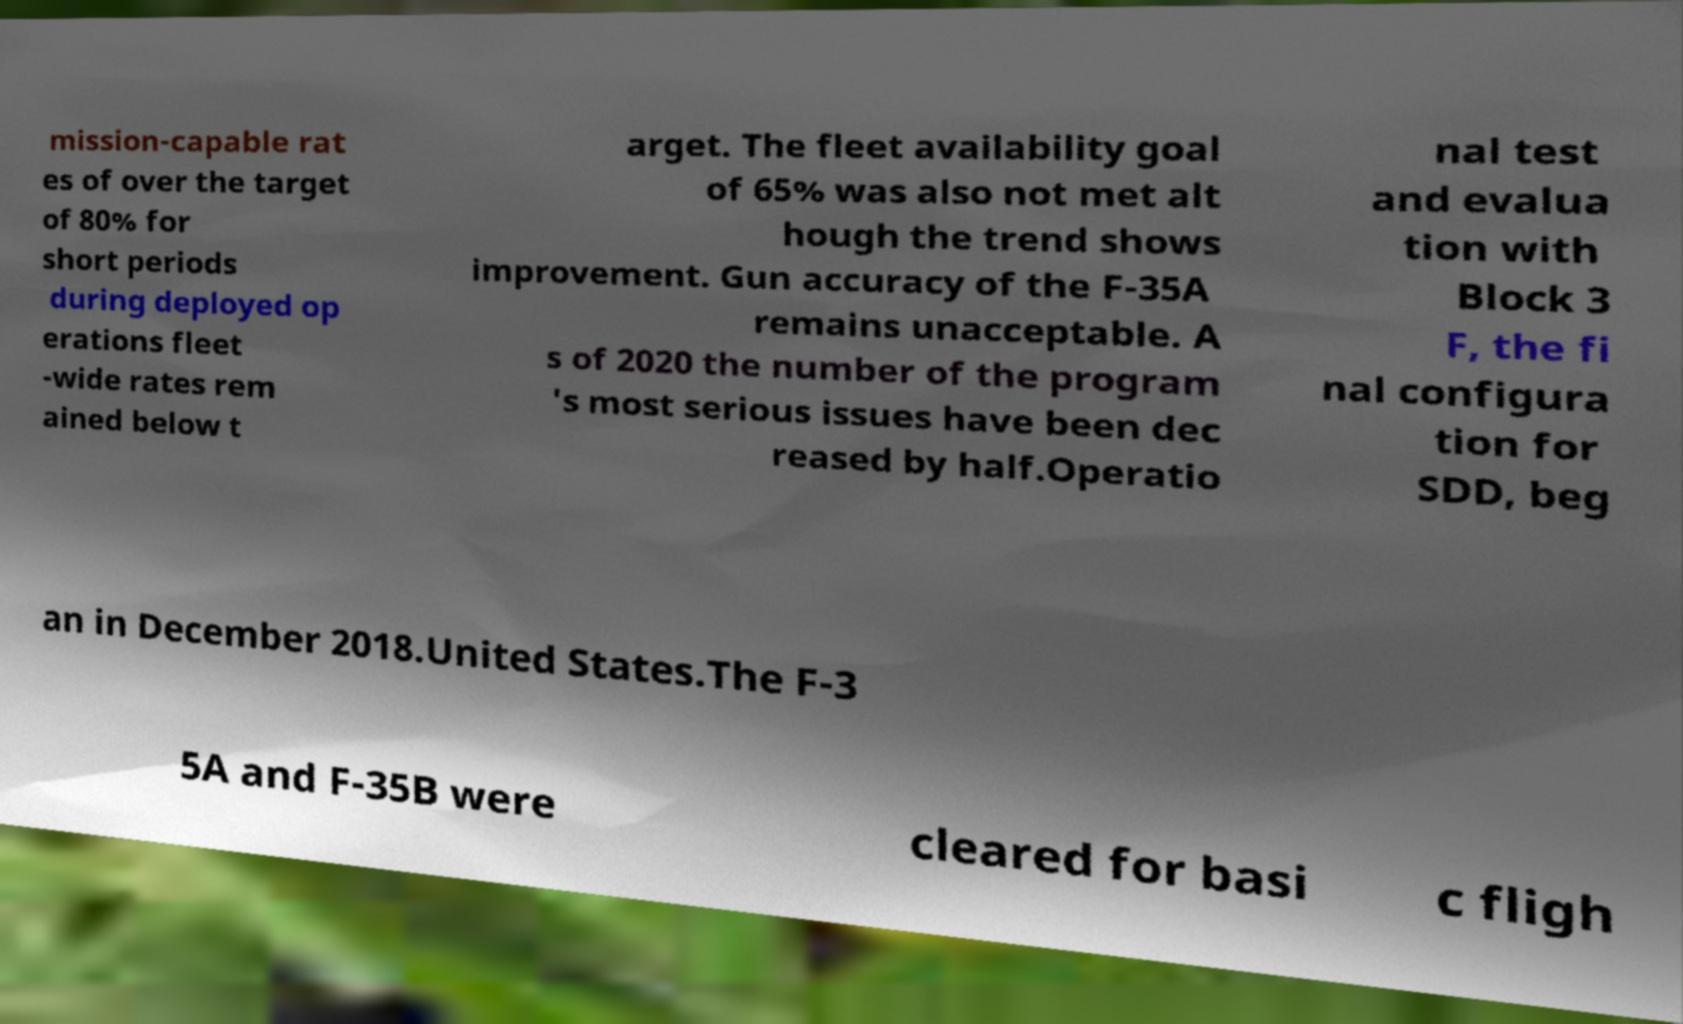Please identify and transcribe the text found in this image. mission-capable rat es of over the target of 80% for short periods during deployed op erations fleet -wide rates rem ained below t arget. The fleet availability goal of 65% was also not met alt hough the trend shows improvement. Gun accuracy of the F-35A remains unacceptable. A s of 2020 the number of the program 's most serious issues have been dec reased by half.Operatio nal test and evalua tion with Block 3 F, the fi nal configura tion for SDD, beg an in December 2018.United States.The F-3 5A and F-35B were cleared for basi c fligh 